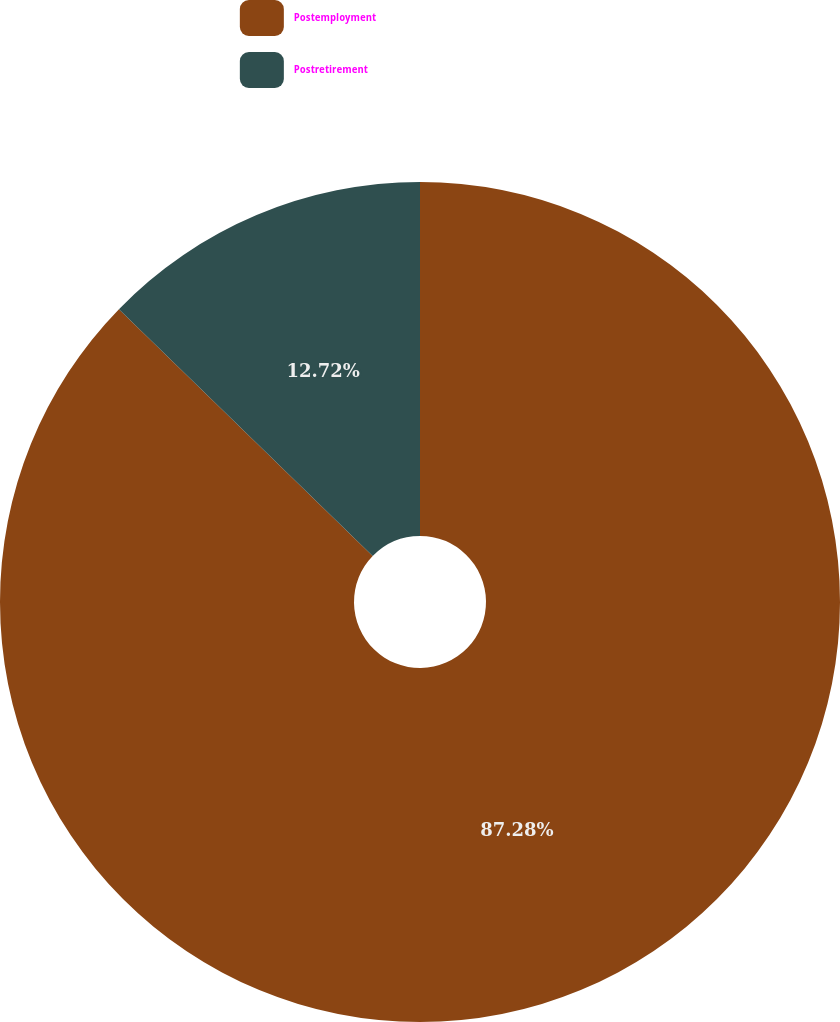Convert chart. <chart><loc_0><loc_0><loc_500><loc_500><pie_chart><fcel>Postemployment<fcel>Postretirement<nl><fcel>87.28%<fcel>12.72%<nl></chart> 